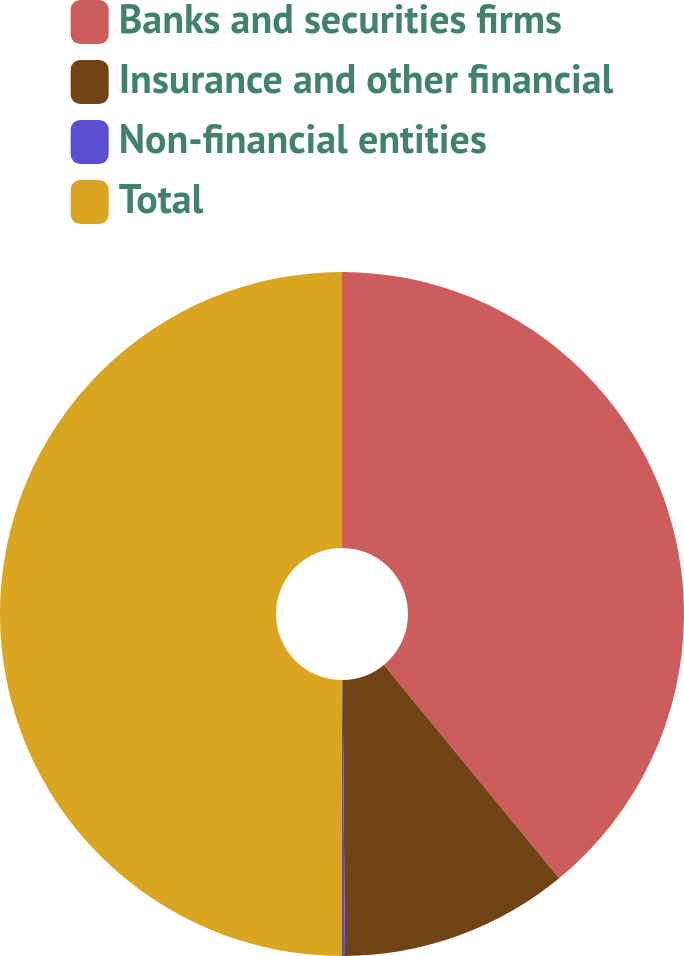Convert chart to OTSL. <chart><loc_0><loc_0><loc_500><loc_500><pie_chart><fcel>Banks and securities firms<fcel>Insurance and other financial<fcel>Non-financial entities<fcel>Total<nl><fcel>39.05%<fcel>10.81%<fcel>0.14%<fcel>50.0%<nl></chart> 